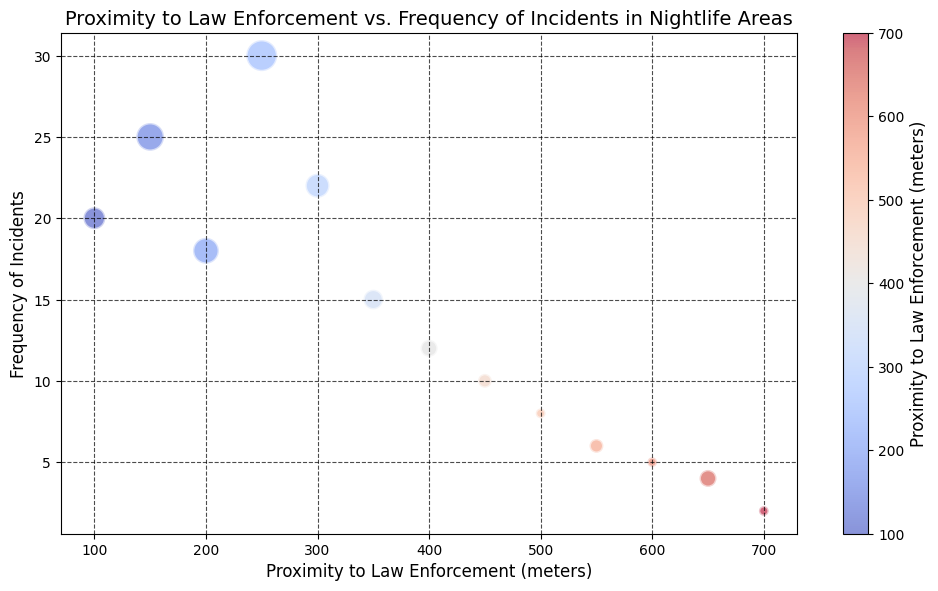What is the frequency of incidents when the proximity to law enforcement is 400 meters? To find the answer, locate the bubble corresponding to 400 meters on the x-axis and read its value on the y-axis, which represents the frequency of incidents.
Answer: 12 Which area has the highest frequency of incidents, and what is its proximity to law enforcement? Identify the bubble with the highest y-axis value (frequency of incidents). Then, check its corresponding x-axis value (proximity to law enforcement).
Answer: 250 meters, 30 incidents What is the average frequency of incidents for areas within 300 to 500 meters of law enforcement? Find the bubbles in the x-axis range of 300 to 500 meters and calculate the average of their y-axis values (frequency of incidents). The areas are: 300m (22 incidents), 350m (15 incidents), 400m (12 incidents), 450m (10 incidents), and 500m (8 incidents). The average is (22 + 15 + 12 + 10 + 8) / 5 = 13.4.
Answer: 13.4 How does the frequency of incidents change with increasing proximity to law enforcement? Observe the trend in the scatter plot as the x-axis values decrease (indicating closer proximity). Generally, bubbles lower in the y-axis (fewer incidents) are found at higher proximity values, suggesting frequency decreases as proximity increases.
Answer: Decreases Compare the number of businesses in areas 200 meters and 450 meters from law enforcement. Locate the bubbles for 200 meters and 450 meters on the x-axis and compare their sizes, representing the number of businesses. 200 meters has 7 businesses, and 450 meters has 2 businesses.
Answer: 200m: 7 businesses, 450m: 2 businesses What is the relationship between the color of the bubbles and their proximity to law enforcement? Examine the scatter plot's color gradient and its mapping to proximity values. Bubbles near the left (closer to law enforcement) are cooler (bluish), and those on the right are warmer (reddish) in color.
Answer: Bubbles closer to law enforcement are blue; farther bubbles are red What is the frequency of incidents in the area with the least number of businesses? Identify the smallest bubble (smallest size). The smallest bubble represents 1 business, which corresponds to 700 meters on the x-axis, with 2 incidents as the y-axis value.
Answer: 2 incidents Which proximity range to law enforcement shows the densest cluster of bubbles? Assess the spread of bubbles on the x-axis to identify where they are most concentrated. Bubbles seem densest between 300 and 500 meters.
Answer: 300-500 meters Is there any area with a proximity greater than 500 meters that has more than 5 incidents? Examine bubbles on the x-axis greater than 500 meters and check their respective y-axis values. The closest values to this range (550m, 600m, 650m, 700m), only have incidents of 6, 5, 4, and 2, all less than 5 incidents.
Answer: No 